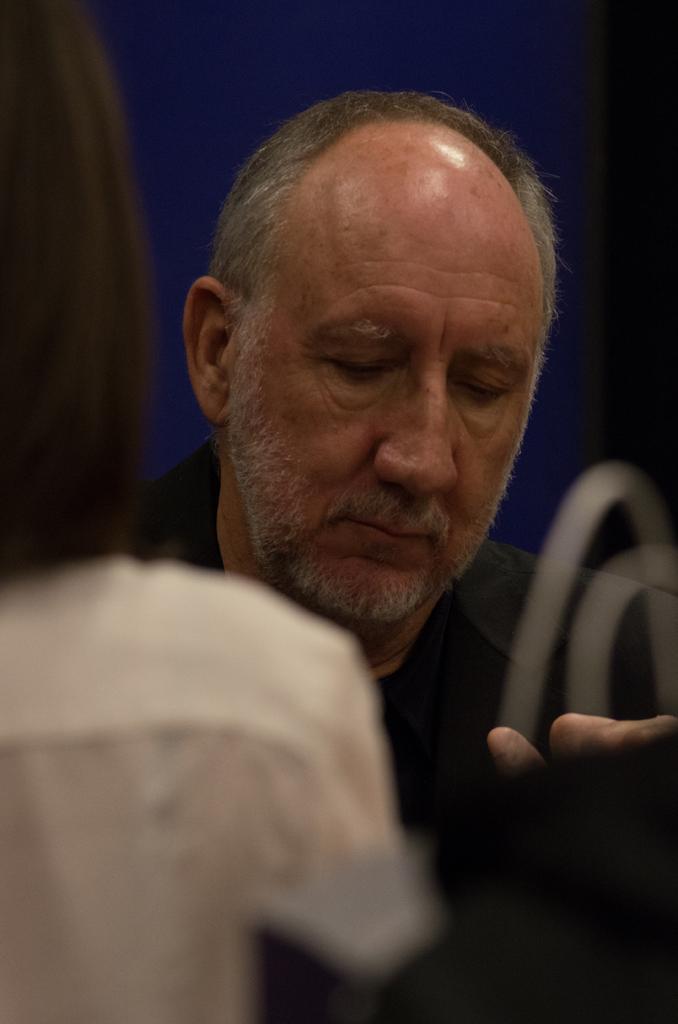How would you summarize this image in a sentence or two? In this image I can see a person face and background is in blue color. In front I can see a white color object. 